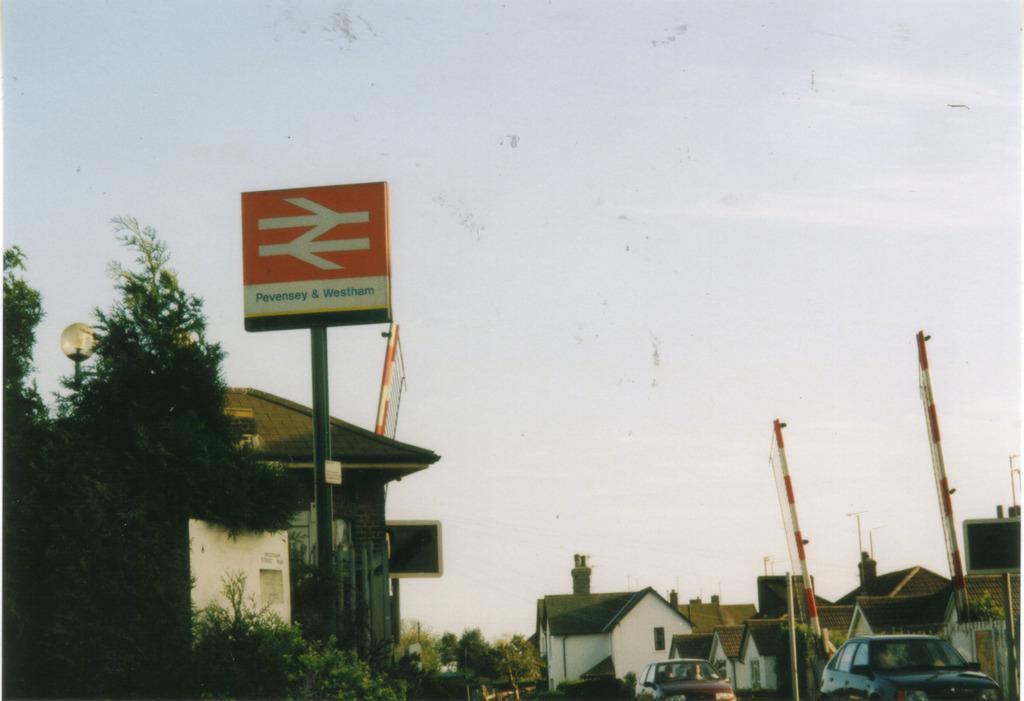In one or two sentences, can you explain what this image depicts? In this picture we can see houses, vehicles, name boards, here we can see a street light, poles, trees, some objects and we can see sky in the background. 